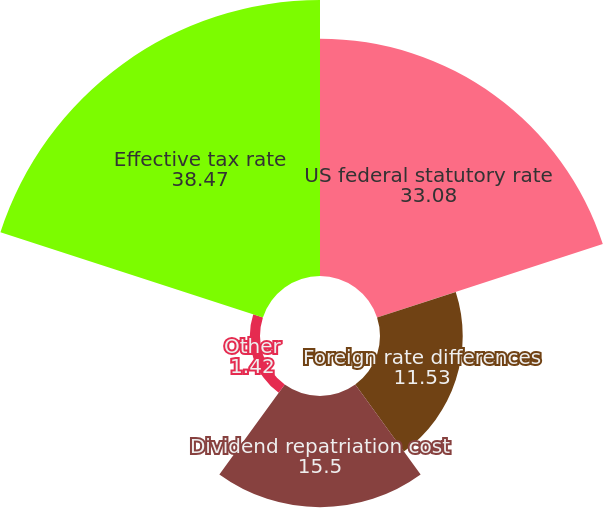Convert chart. <chart><loc_0><loc_0><loc_500><loc_500><pie_chart><fcel>US federal statutory rate<fcel>Foreign rate differences<fcel>Dividend repatriation cost<fcel>Other<fcel>Effective tax rate<nl><fcel>33.08%<fcel>11.53%<fcel>15.5%<fcel>1.42%<fcel>38.47%<nl></chart> 